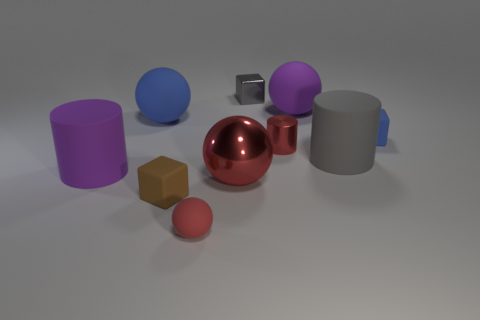There is a large matte thing that is both to the right of the large blue matte ball and in front of the tiny blue object; what shape is it?
Your answer should be very brief. Cylinder. There is a large cylinder that is to the left of the small metal cube; is it the same color as the rubber cube that is right of the red metallic cylinder?
Provide a short and direct response. No. What size is the metal object that is the same color as the metallic sphere?
Ensure brevity in your answer.  Small. Are there any small cyan things made of the same material as the large red ball?
Your answer should be compact. No. Are there an equal number of red matte balls right of the red rubber object and red rubber things that are to the right of the gray cube?
Provide a short and direct response. Yes. How big is the sphere that is to the right of the small cylinder?
Offer a very short reply. Large. What is the material of the large purple object to the left of the rubber block in front of the small blue object?
Your response must be concise. Rubber. What number of blocks are behind the big cylinder left of the matte sphere that is in front of the gray rubber thing?
Give a very brief answer. 2. Does the small block to the left of the small sphere have the same material as the object to the left of the large blue rubber object?
Your answer should be compact. Yes. There is a large thing that is the same color as the small metallic cylinder; what is its material?
Your answer should be compact. Metal. 